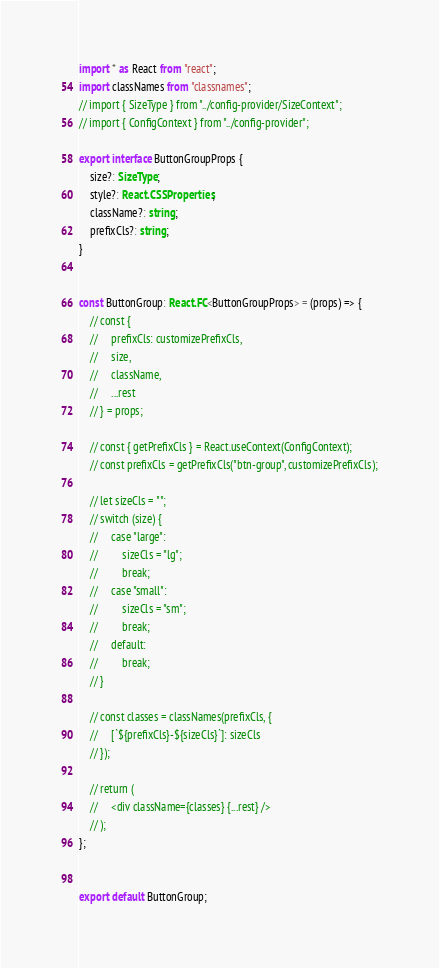<code> <loc_0><loc_0><loc_500><loc_500><_TypeScript_>import * as React from "react";
import classNames from "classnames";
// import { SizeType } from "../config-provider/SizeContext";
// import { ConfigContext } from "../config-provider";

export interface ButtonGroupProps {
    size?: SizeType;
    style?: React.CSSProperties;
    className?: string;
    prefixCls?: string;
}


const ButtonGroup: React.FC<ButtonGroupProps> = (props) => {
    // const {
    //     prefixCls: customizePrefixCls,
    //     size,
    //     className,
    //     ...rest
    // } = props;

    // const { getPrefixCls } = React.useContext(ConfigContext);
    // const prefixCls = getPrefixCls("btn-group", customizePrefixCls);

    // let sizeCls = "";
    // switch (size) {
    //     case "large":
    //         sizeCls = "lg";
    //         break;
    //     case "small":
    //         sizeCls = "sm";
    //         break;
    //     default:
    //         break;
    // }

    // const classes = classNames(prefixCls, {
    //     [`${prefixCls}-${sizeCls}`]: sizeCls
    // });

    // return (
    //     <div className={classes} {...rest} />
    // );
};


export default ButtonGroup;
</code> 